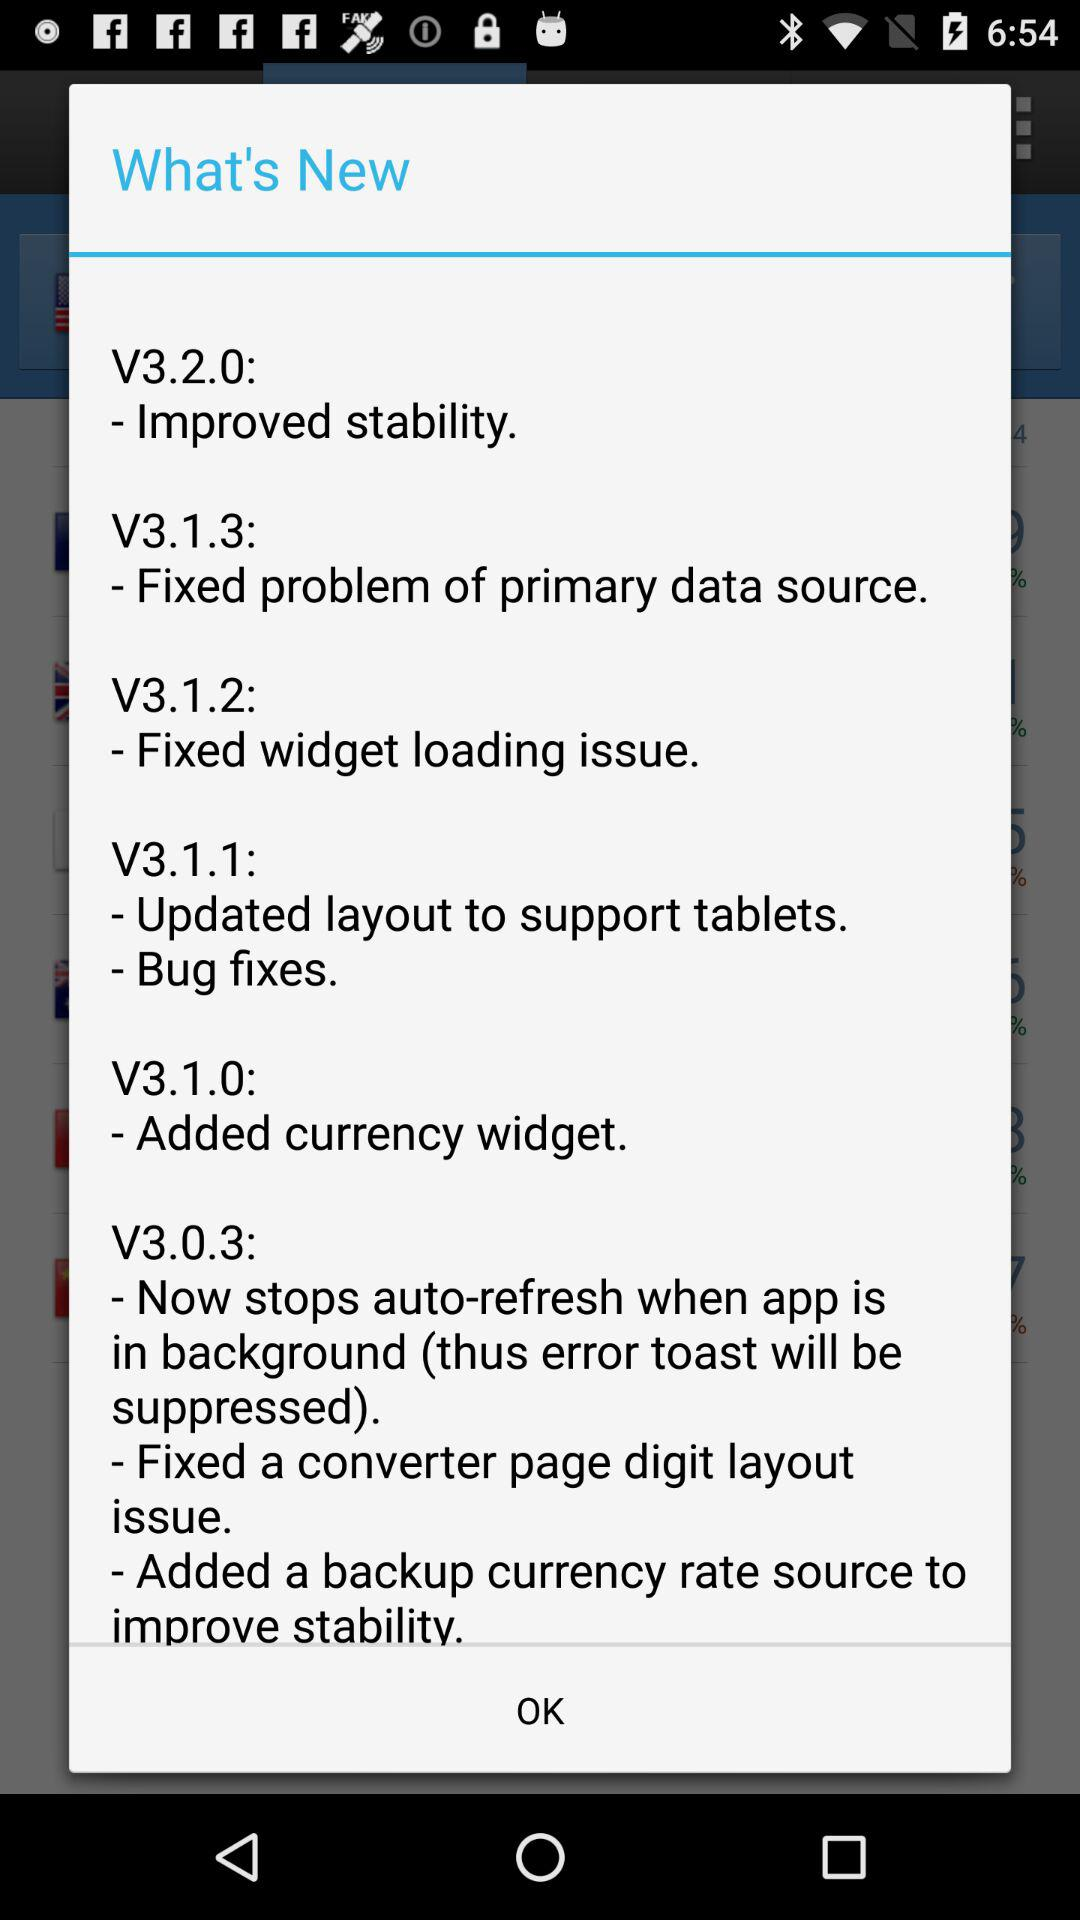Which version does the added currency widget relate to? The added currency widget relates to version V3.1.0. 